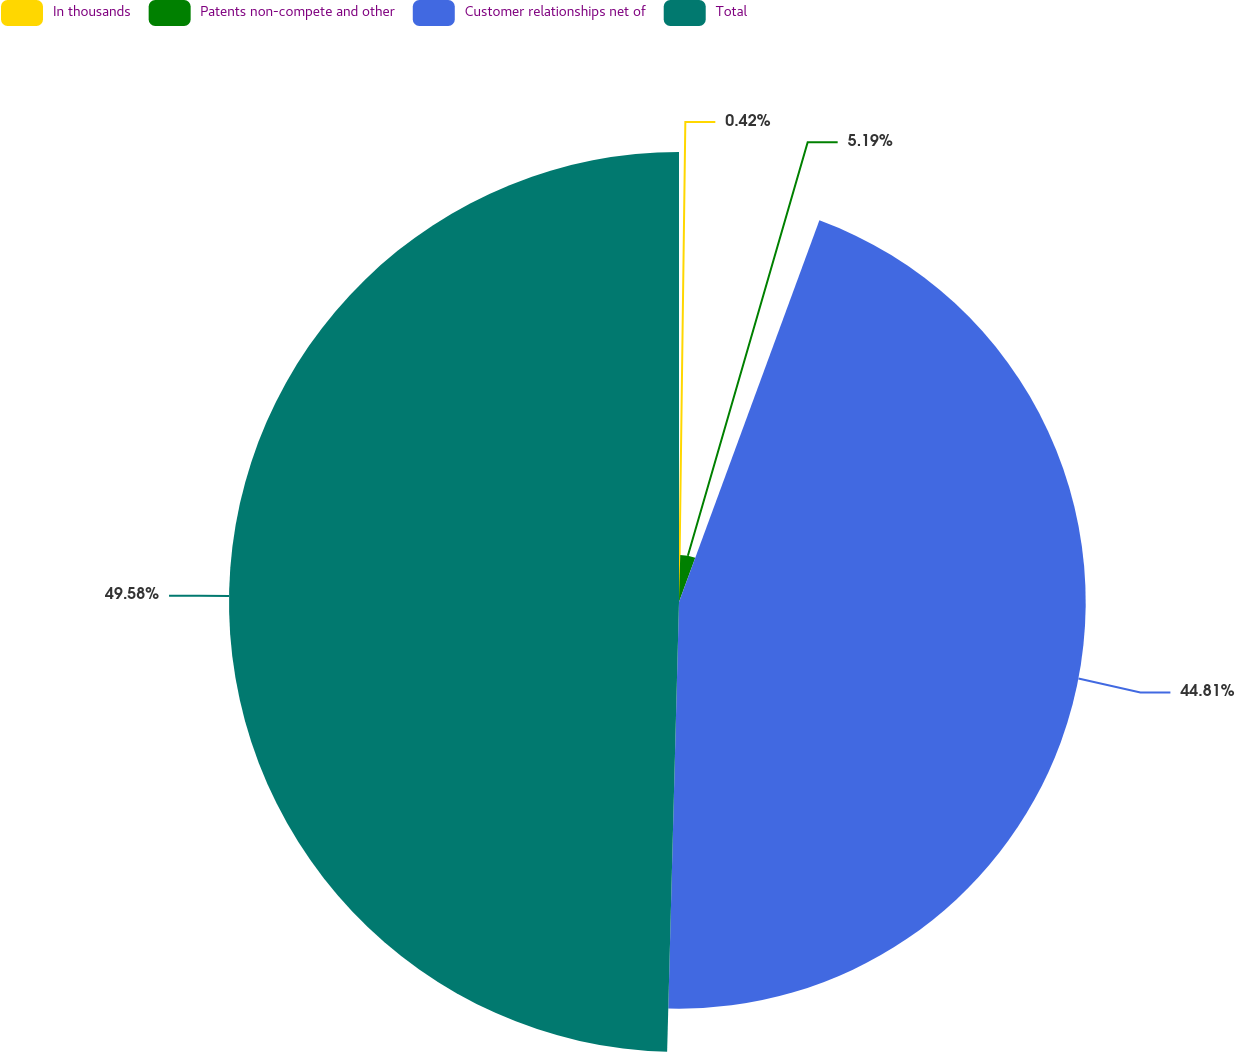Convert chart. <chart><loc_0><loc_0><loc_500><loc_500><pie_chart><fcel>In thousands<fcel>Patents non-compete and other<fcel>Customer relationships net of<fcel>Total<nl><fcel>0.42%<fcel>5.19%<fcel>44.81%<fcel>49.58%<nl></chart> 